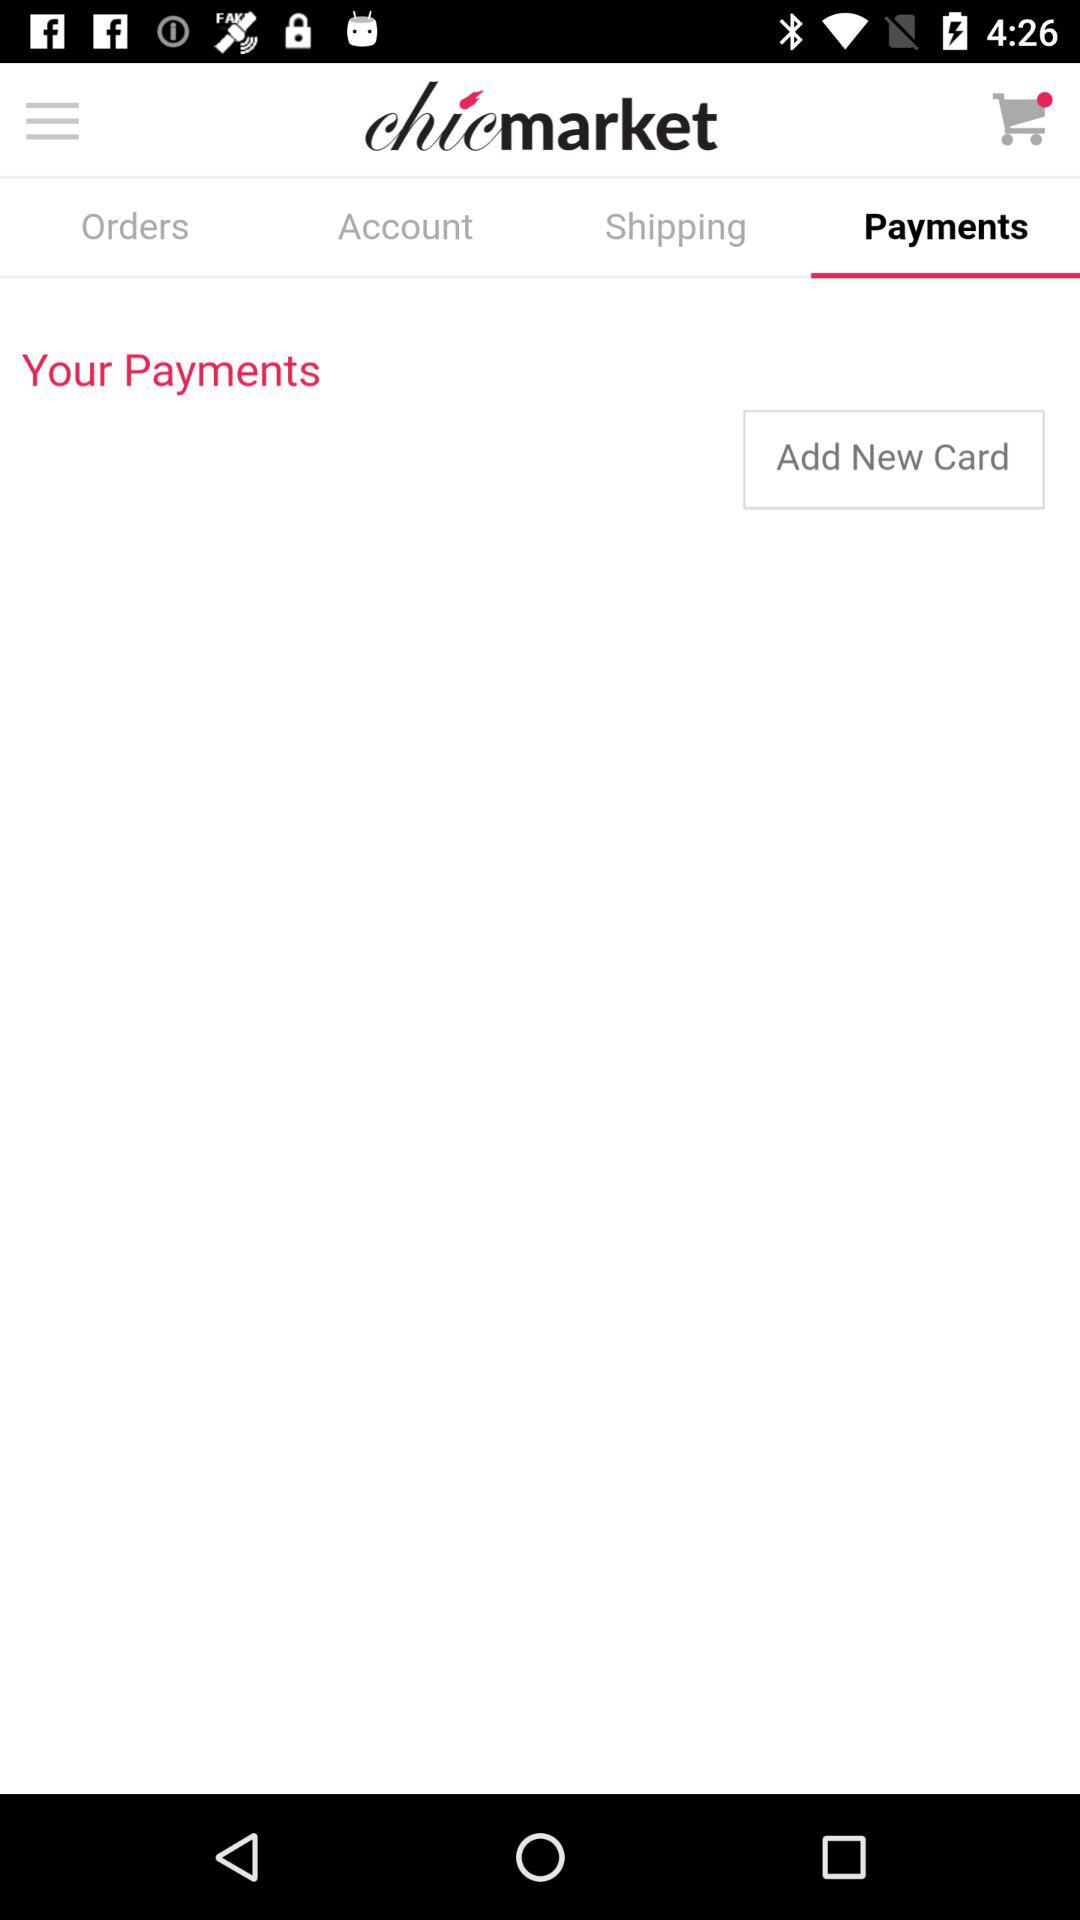Which tab is selected? The selected tab is "Payments". 